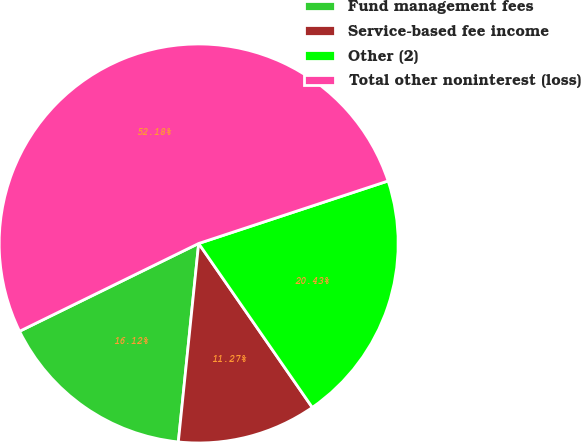<chart> <loc_0><loc_0><loc_500><loc_500><pie_chart><fcel>Fund management fees<fcel>Service-based fee income<fcel>Other (2)<fcel>Total other noninterest (loss)<nl><fcel>16.12%<fcel>11.27%<fcel>20.43%<fcel>52.18%<nl></chart> 